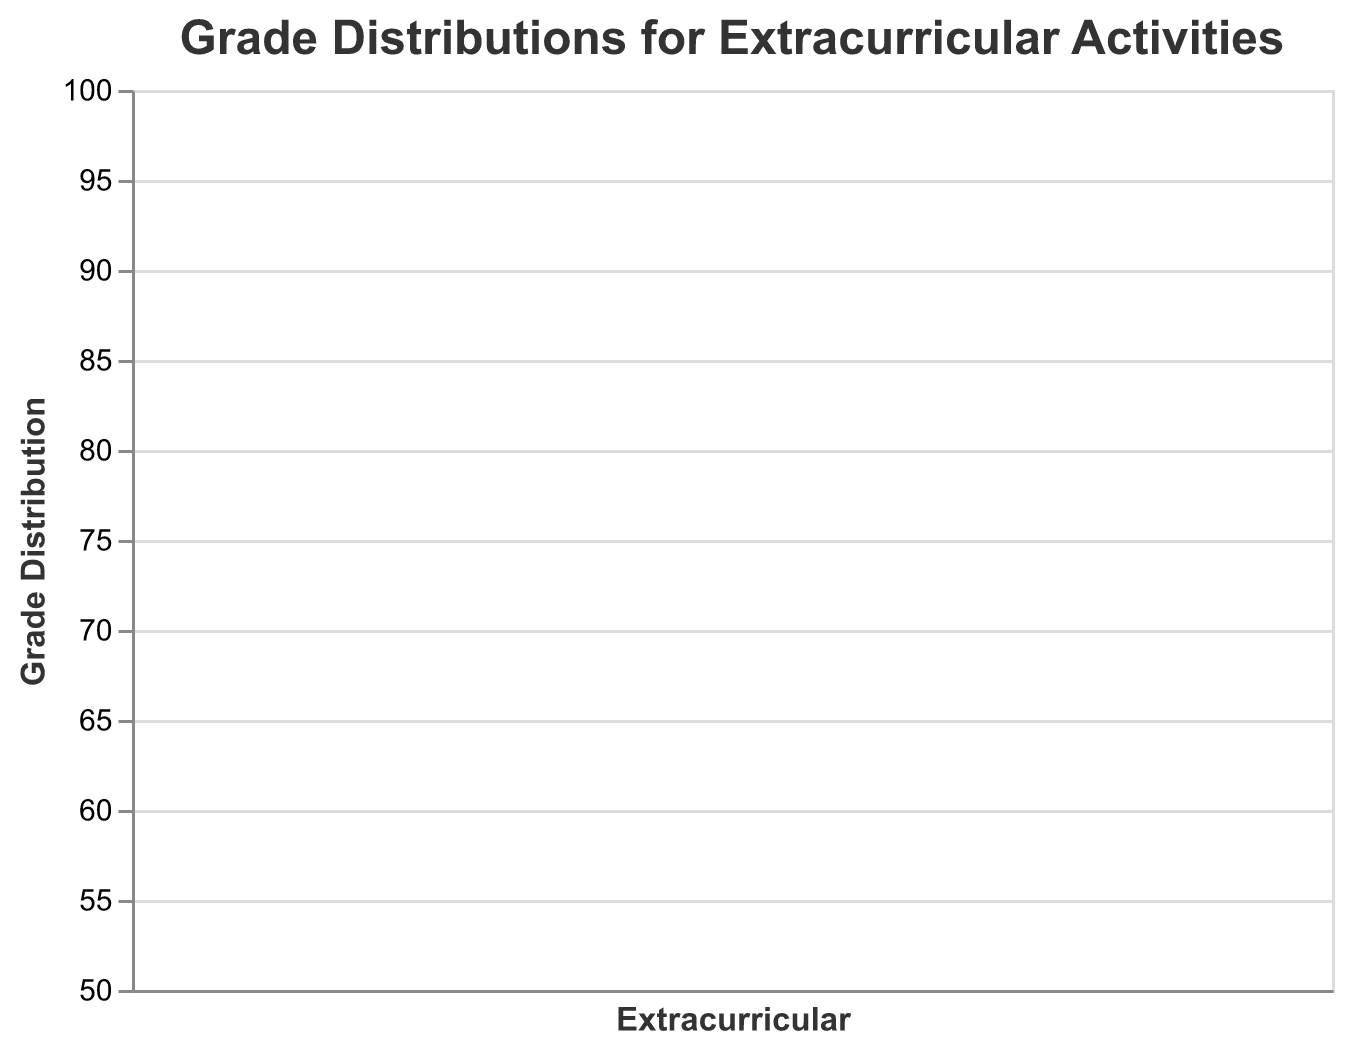What's the median grade for students involved in Music? Look at the box representing "Music" and find the line inside the box, which shows the median value.
Answer: 80 Which extracurricular activity has the highest maximum grade? Check the top end of each candlestick to find the maximum values. The highest maximum grade corresponds to the Science Club.
Answer: Science Club What's the interquartile range (IQR) for students involved in Art? IQR can be found by subtracting Q1 (65) from Q3 (75). 75 - 65 = 10
Answer: 10 Which two activities have the closest median grade? Examine the median values (the line within the boxes) and compare them. Sports (75) and Volunteering (78) are the closest.
Answer: Sports and Volunteering What is the range of grades for the Drama activity? Subtract the minimum value (55) from the maximum value (75). 75 - 55 = 20
Answer: 20 Which extracurricular activity has the broadest range of grades? Calculate the range for each activity (Max - Min) and compare them. Drama has the broadest range: 75 - 55 = 20.
Answer: Drama What is the minimum grade for the Volunteering activity? Look at the bottom end of the candlestick for Volunteering.
Answer: 68 How does the median grade for Sports compare to the median for Drama? Find the median values for Sports (75) and Drama (65) and compare them. Sports has a higher median.
Answer: Sports has a higher median What is the median grade difference between Science Club and Art? Subtract the median of Art (70) from the median of Science Club (85). 85 - 70 = 15
Answer: 15 Which extracurricular activity shows the smallest interquartile range (IQR)? Calculate the IQR for each activity (Q3 - Q1) and compare them. Drama has the smallest IQR: 70 - 60 = 10.
Answer: Drama 